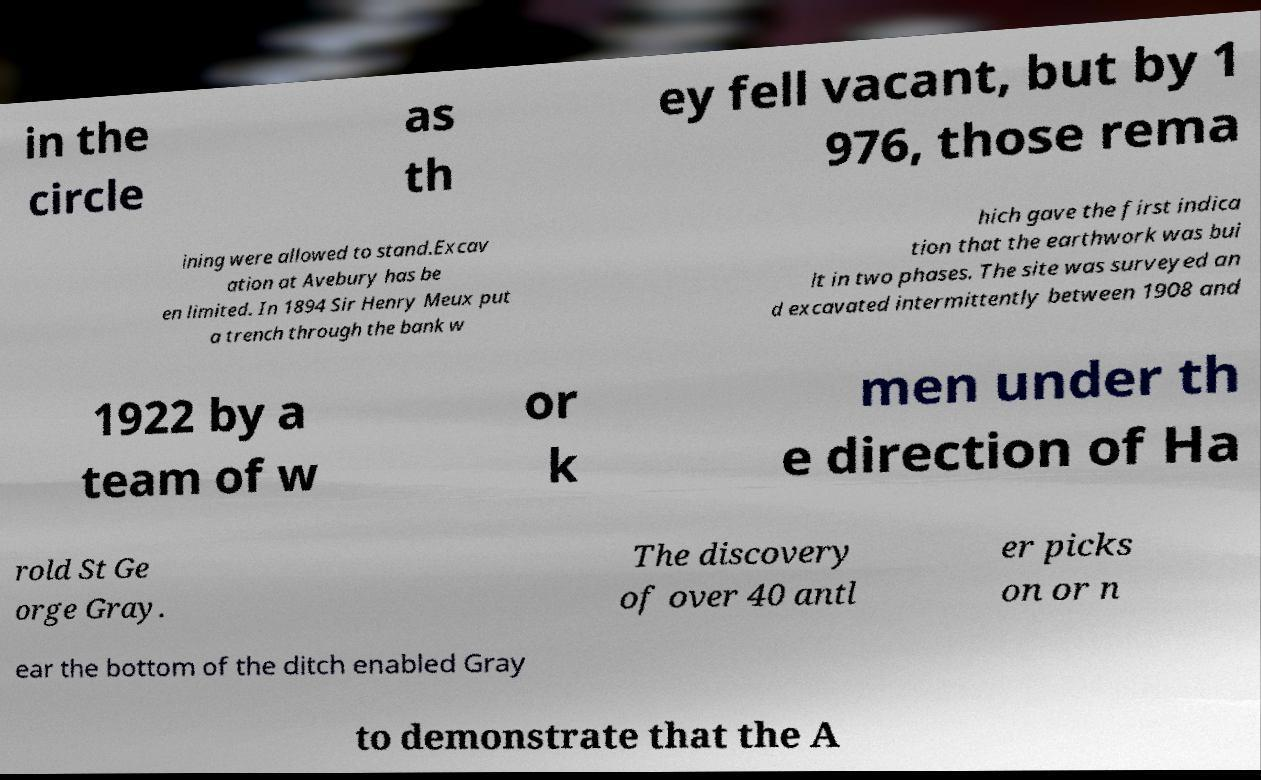There's text embedded in this image that I need extracted. Can you transcribe it verbatim? in the circle as th ey fell vacant, but by 1 976, those rema ining were allowed to stand.Excav ation at Avebury has be en limited. In 1894 Sir Henry Meux put a trench through the bank w hich gave the first indica tion that the earthwork was bui lt in two phases. The site was surveyed an d excavated intermittently between 1908 and 1922 by a team of w or k men under th e direction of Ha rold St Ge orge Gray. The discovery of over 40 antl er picks on or n ear the bottom of the ditch enabled Gray to demonstrate that the A 